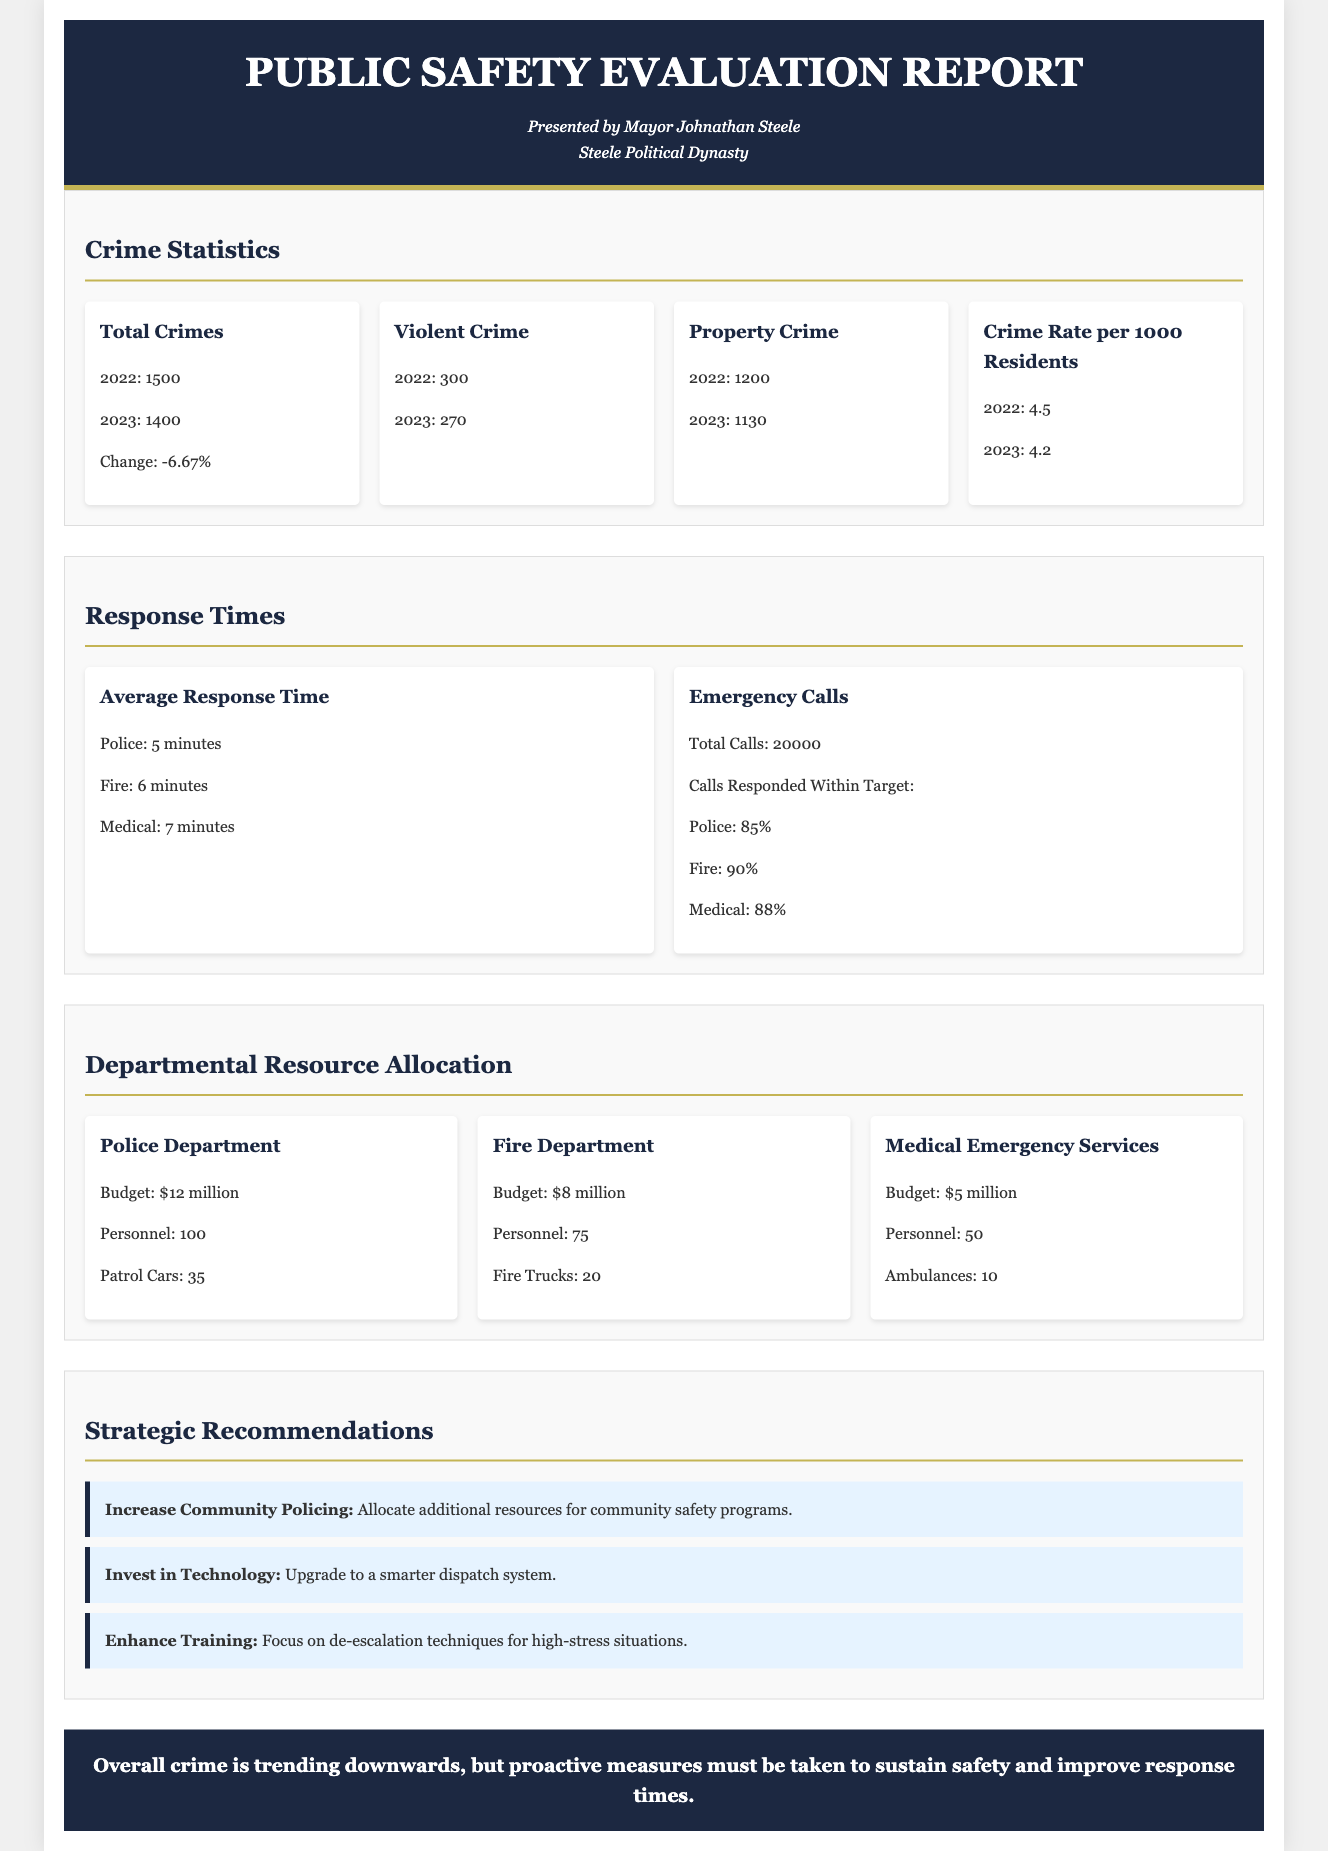What was the total number of crimes in 2023? The total number of crimes in 2023, as stated in the report, is 1400.
Answer: 1400 What is the average police response time? The average police response time is listed as 5 minutes in the report.
Answer: 5 minutes What was the change in property crime from 2022 to 2023? The report indicates a decrease in property crime from 1200 in 2022 to 1130 in 2023, showing a change of -5.83%.
Answer: -5.83% What percentage of emergency calls were responded to by the Fire Department within the target time? According to the report, the Fire Department responded to 90% of emergency calls within the target time.
Answer: 90% What is the budget for the Police Department? The budget for the Police Department is $12 million, as detailed in the allocation section.
Answer: $12 million How many ambulances are available in Medical Emergency Services? The report lists the number of ambulances in Medical Emergency Services as 10.
Answer: 10 What recommendation is made regarding community policing? The report recommends to allocate additional resources for community safety programs under the section on strategic recommendations.
Answer: Increase Community Policing How does the total crime rate per 1000 residents compare from 2022 to 2023? The total crime rate decreased from 4.5 in 2022 to 4.2 in 2023, indicating a positive trend.
Answer: Decreased What is the total personnel in the Fire Department? The Fire Department has a total personnel count of 75, as mentioned in the resource allocation section.
Answer: 75 